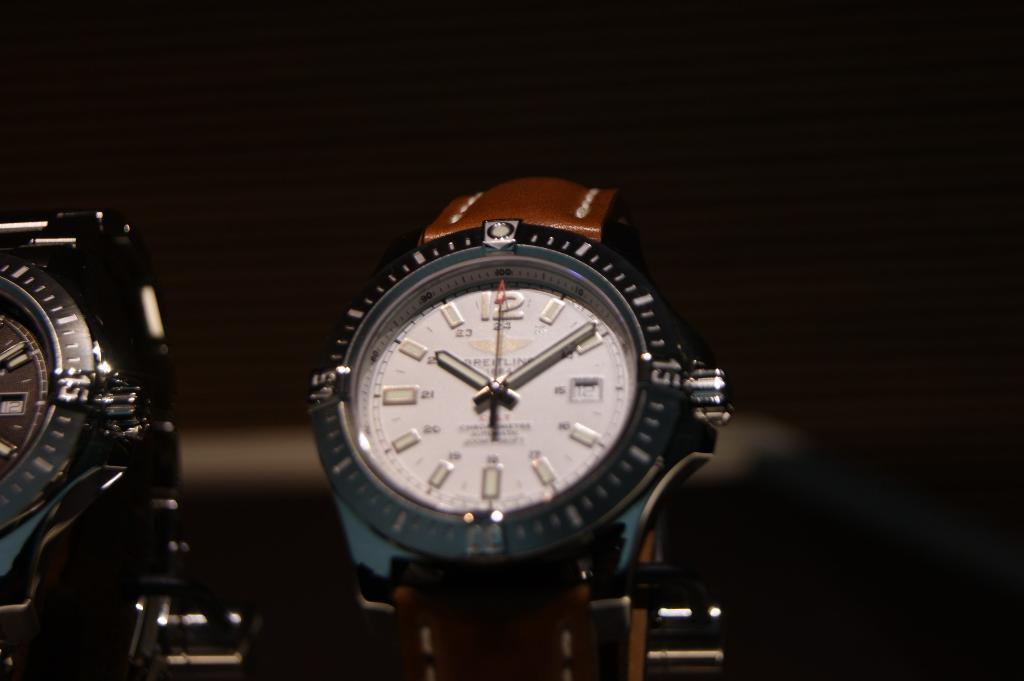Provide a one-sentence caption for the provided image. Two shiny Breitling Watches on display with a dark background. 